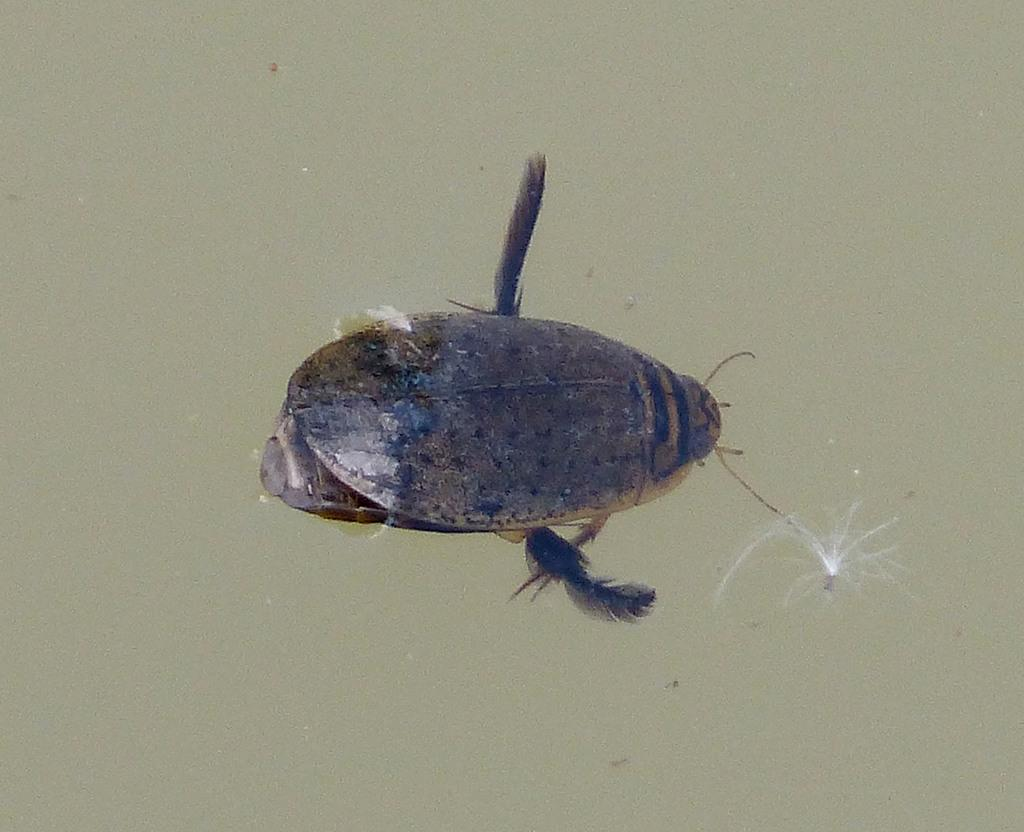What type of creature is in the water in the image? There is an insect in the water in the image. What is the reaction of the insect when it sees the elbow in the image? There is no elbow present in the image, and therefore no reaction from the insect can be observed. 